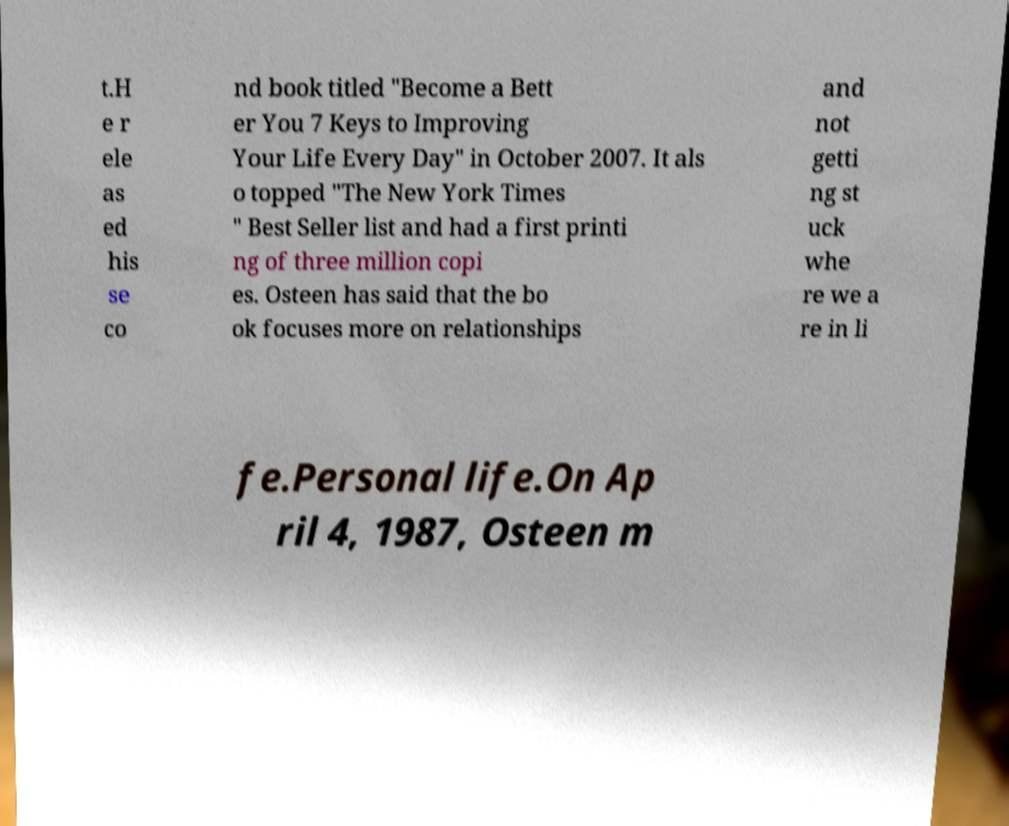There's text embedded in this image that I need extracted. Can you transcribe it verbatim? t.H e r ele as ed his se co nd book titled "Become a Bett er You 7 Keys to Improving Your Life Every Day" in October 2007. It als o topped "The New York Times " Best Seller list and had a first printi ng of three million copi es. Osteen has said that the bo ok focuses more on relationships and not getti ng st uck whe re we a re in li fe.Personal life.On Ap ril 4, 1987, Osteen m 